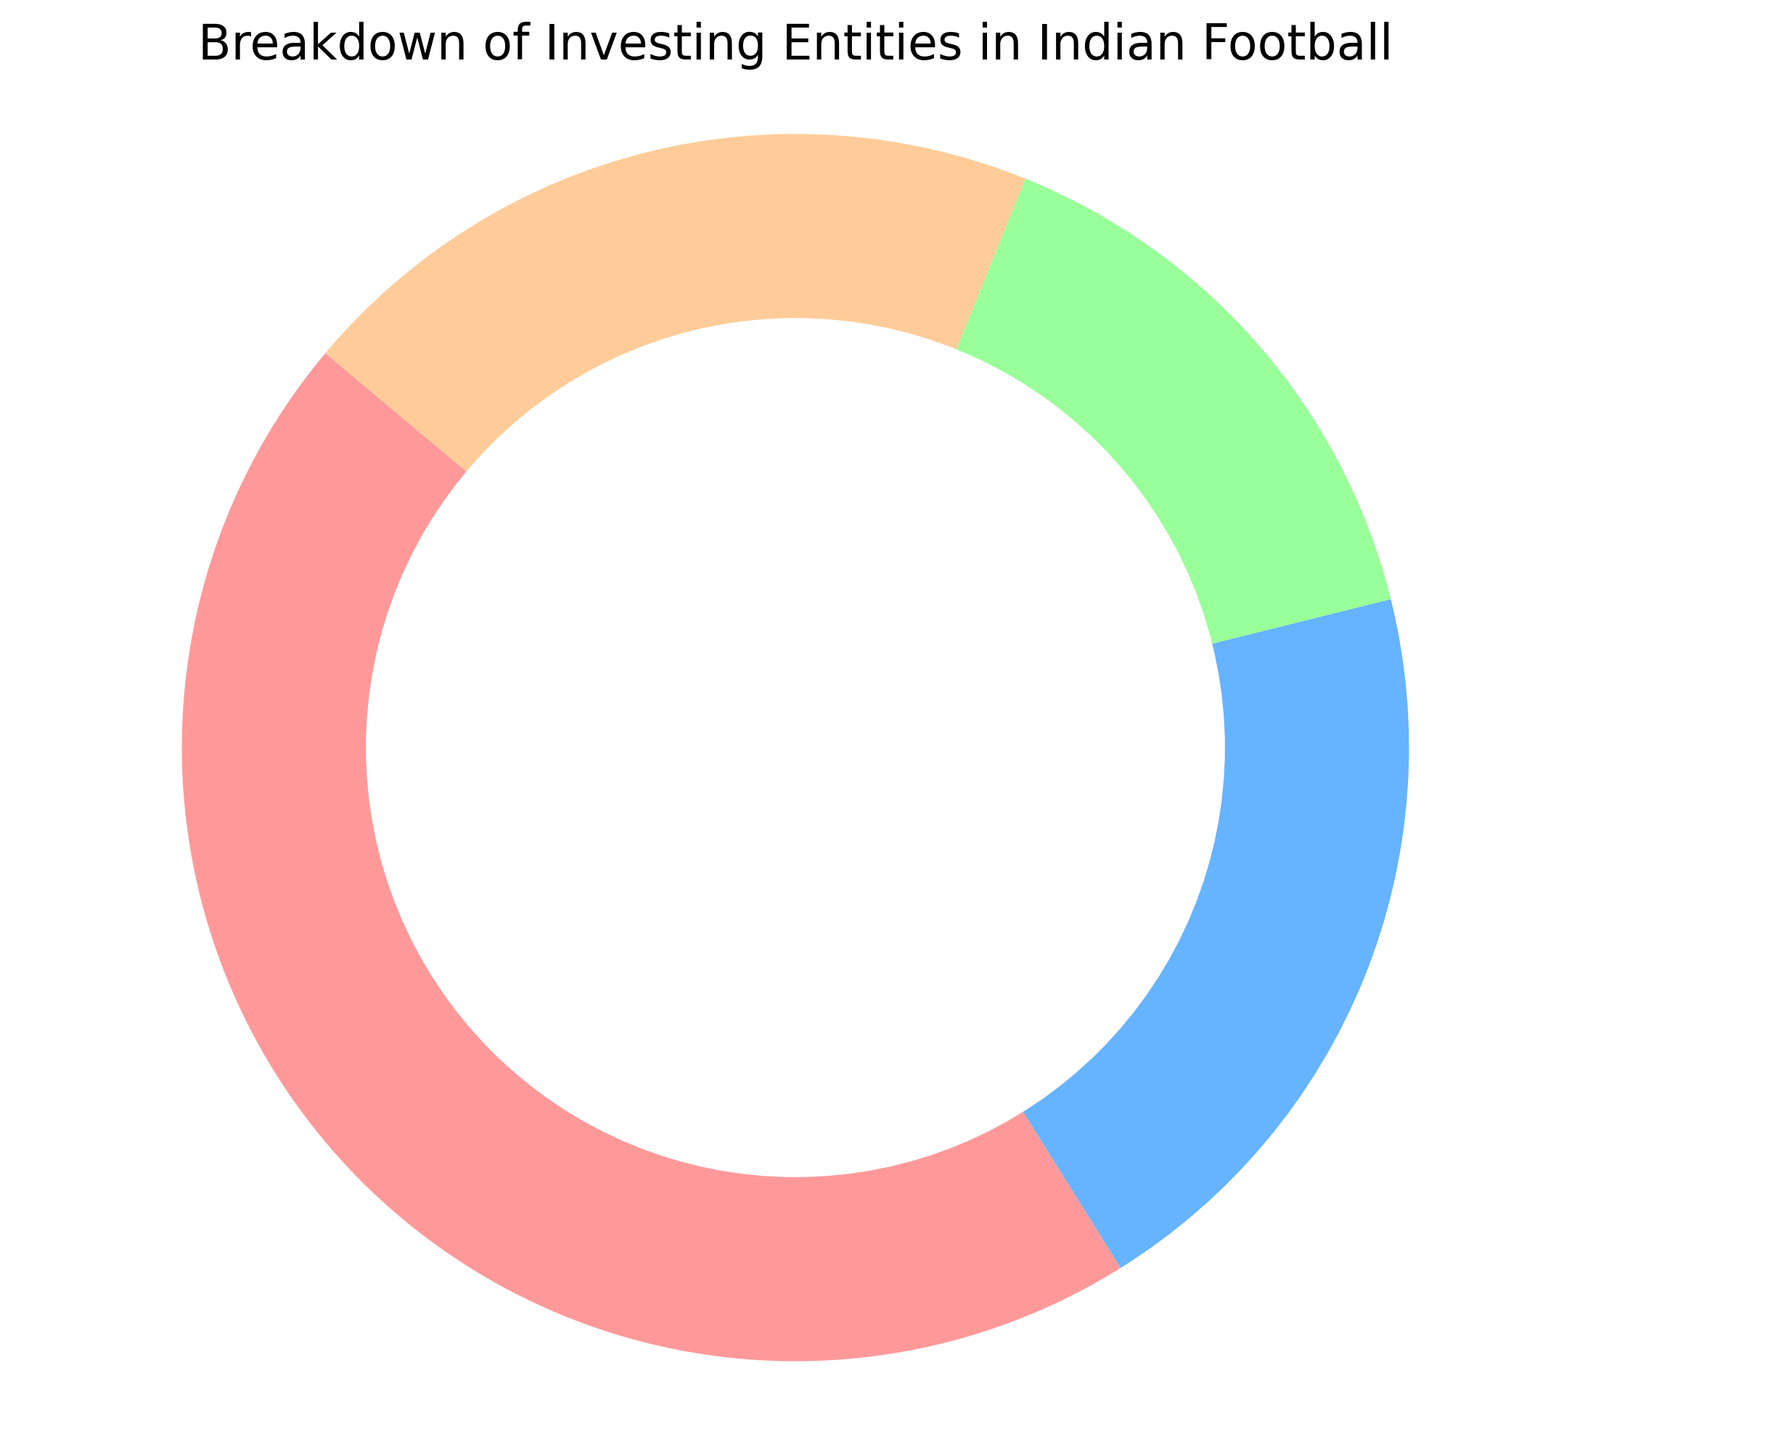What percentage of investment comes from the Government? Look at the slice labeled as "Government" on the pie chart, which shows the investment percentage.
Answer: 45% Which entities have an equal share of investment? Observe the slices on the pie chart to see which entities have the same percentage. The "Domestic Clubs" and "Independent Investors" both have a 20% share.
Answer: Domestic Clubs and Independent Investors What is the total percentage of investment from domestic sources (Government and Domestic Clubs)? Add the percentages from the "Government" and "Domestic Clubs" slices. 45% (Government) + 20% (Domestic Clubs) = 65%.
Answer: 65% How much more does the Government invest compared to International Clubs? Subtract the percentage of investment from International Clubs from that of the Government. 45% (Government) - 15% (International Clubs) = 30%.
Answer: 30% Which entity has the smallest investment percentage? Identify the slice with the smallest percentage on the pie chart. The "International Clubs" slice shows 15%.
Answer: International Clubs What is the average investment percentage across all entities? Calculate the average by summing the investment percentages and dividing by the number of entities. (45% + 20% + 15% + 20%) / 4 = 100% / 4 = 25%.
Answer: 25% Combine the investment percentages of International Clubs and Independent Investors. What is the total percentage? Add the percentages from the "International Clubs" and "Independent Investors" slices. 15% (International Clubs) + 20% (Independent Investors) = 35%.
Answer: 35% What color represents Domestic Clubs on the pie chart? Identify the color of the slice labeled "Domestic Clubs" in the chart. In the code, this is the second color in the list, which is light blue.
Answer: Light blue 